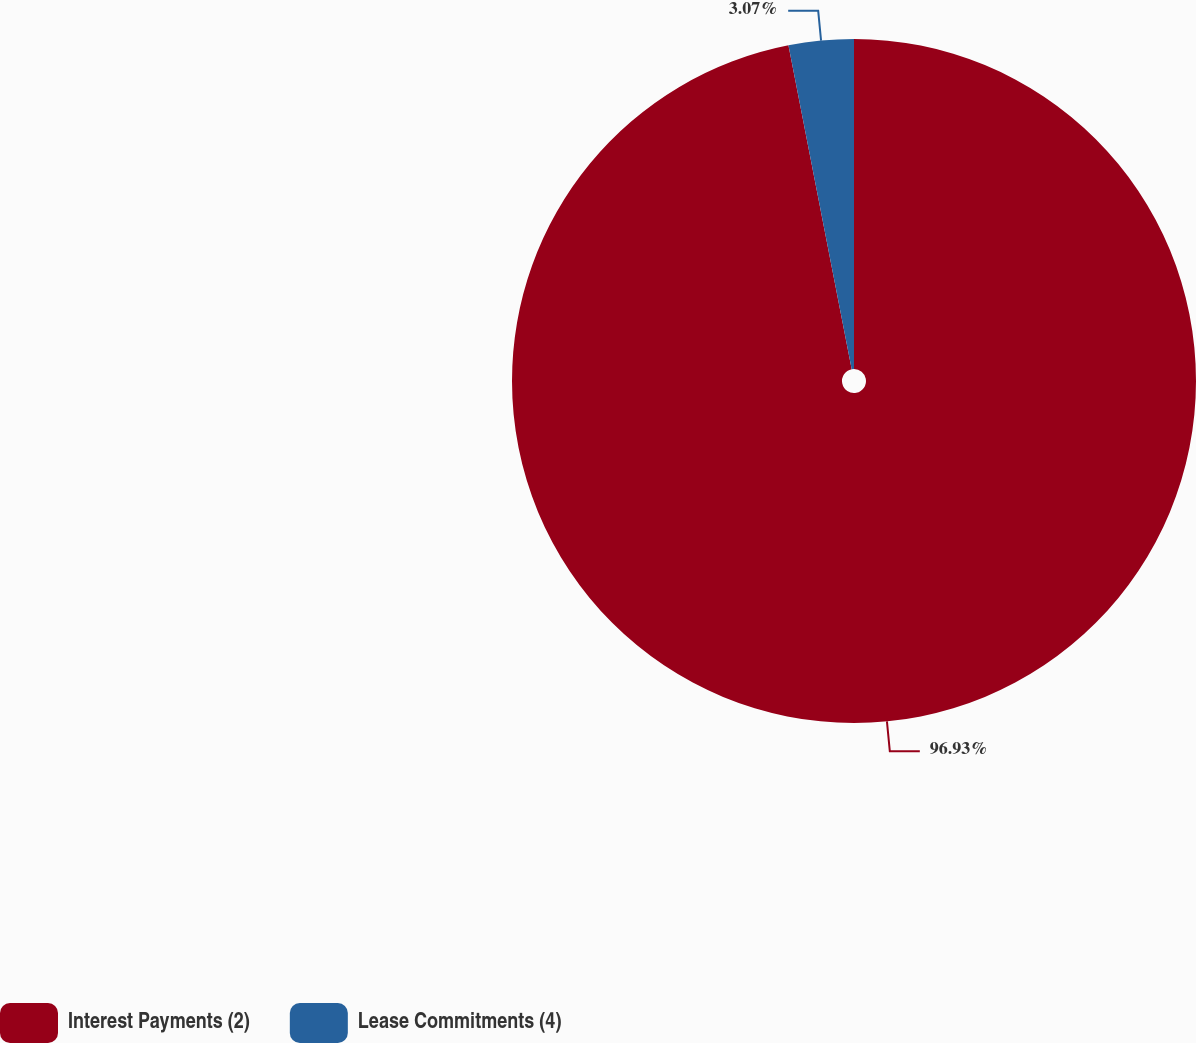Convert chart to OTSL. <chart><loc_0><loc_0><loc_500><loc_500><pie_chart><fcel>Interest Payments (2)<fcel>Lease Commitments (4)<nl><fcel>96.93%<fcel>3.07%<nl></chart> 